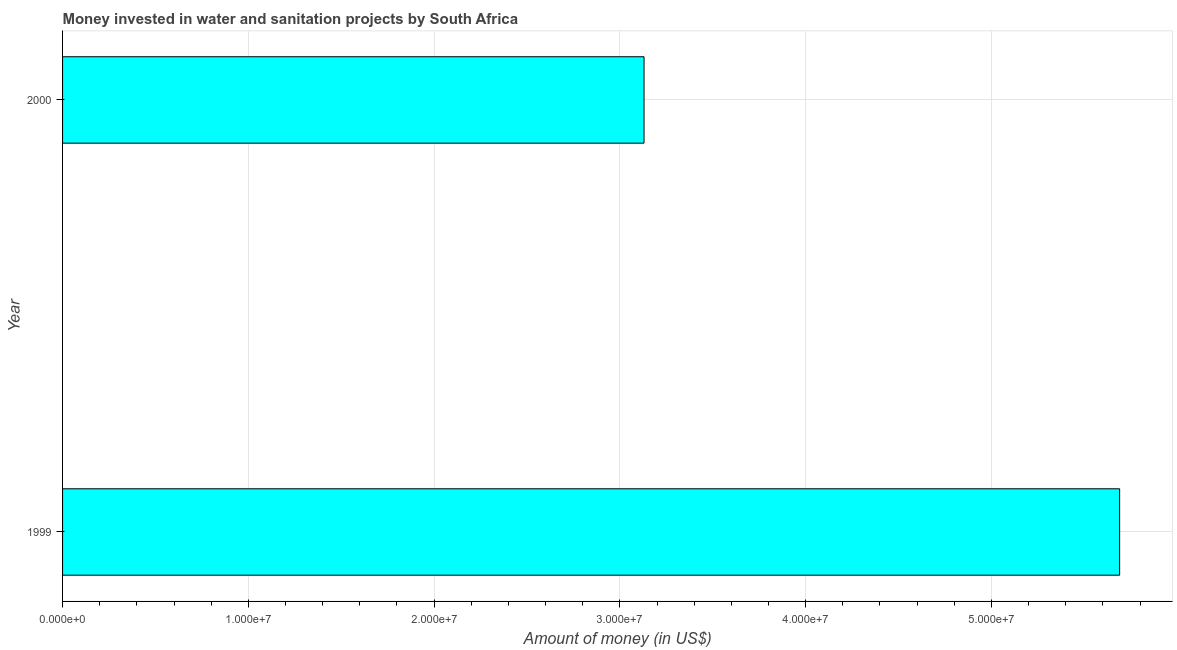Does the graph contain any zero values?
Your answer should be compact. No. What is the title of the graph?
Offer a very short reply. Money invested in water and sanitation projects by South Africa. What is the label or title of the X-axis?
Offer a terse response. Amount of money (in US$). What is the label or title of the Y-axis?
Give a very brief answer. Year. What is the investment in 1999?
Provide a short and direct response. 5.69e+07. Across all years, what is the maximum investment?
Your answer should be very brief. 5.69e+07. Across all years, what is the minimum investment?
Your response must be concise. 3.13e+07. In which year was the investment minimum?
Your answer should be very brief. 2000. What is the sum of the investment?
Make the answer very short. 8.82e+07. What is the difference between the investment in 1999 and 2000?
Make the answer very short. 2.56e+07. What is the average investment per year?
Ensure brevity in your answer.  4.41e+07. What is the median investment?
Make the answer very short. 4.41e+07. What is the ratio of the investment in 1999 to that in 2000?
Your answer should be compact. 1.82. How many bars are there?
Your answer should be very brief. 2. Are all the bars in the graph horizontal?
Offer a terse response. Yes. How many years are there in the graph?
Offer a very short reply. 2. What is the difference between two consecutive major ticks on the X-axis?
Offer a very short reply. 1.00e+07. What is the Amount of money (in US$) in 1999?
Offer a very short reply. 5.69e+07. What is the Amount of money (in US$) of 2000?
Offer a terse response. 3.13e+07. What is the difference between the Amount of money (in US$) in 1999 and 2000?
Offer a very short reply. 2.56e+07. What is the ratio of the Amount of money (in US$) in 1999 to that in 2000?
Offer a terse response. 1.82. 